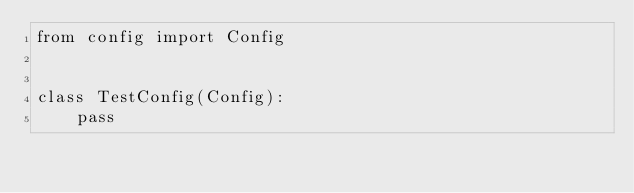<code> <loc_0><loc_0><loc_500><loc_500><_Python_>from config import Config


class TestConfig(Config):
    pass</code> 